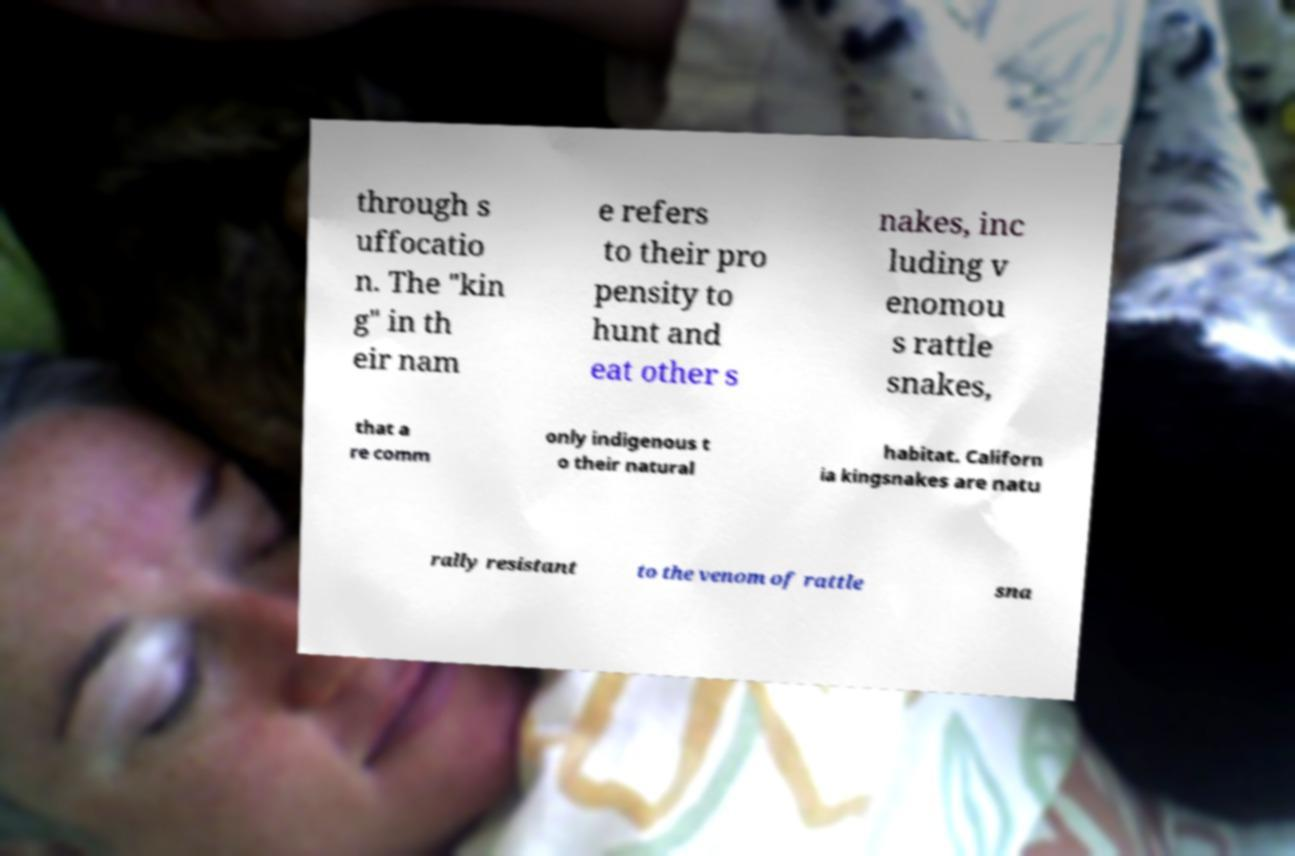Please read and relay the text visible in this image. What does it say? through s uffocatio n. The "kin g" in th eir nam e refers to their pro pensity to hunt and eat other s nakes, inc luding v enomou s rattle snakes, that a re comm only indigenous t o their natural habitat. Californ ia kingsnakes are natu rally resistant to the venom of rattle sna 